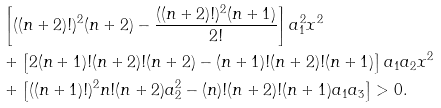Convert formula to latex. <formula><loc_0><loc_0><loc_500><loc_500>& \left [ ( ( n + 2 ) ! ) ^ { 2 } ( n + 2 ) - \frac { ( ( n + 2 ) ! ) ^ { 2 } ( n + 1 ) } { 2 ! } \right ] a _ { 1 } ^ { 2 } x ^ { 2 } \\ & + \left [ 2 ( n + 1 ) ! ( n + 2 ) ! ( n + 2 ) - ( n + 1 ) ! ( n + 2 ) ! ( n + 1 ) \right ] a _ { 1 } a _ { 2 } x ^ { 2 } \\ & + \left [ ( ( n + 1 ) ! ) ^ { 2 } n ! ( n + 2 ) a _ { 2 } ^ { 2 } - ( n ) ! ( n + 2 ) ! ( n + 1 ) a _ { 1 } a _ { 3 } \right ] > 0 .</formula> 